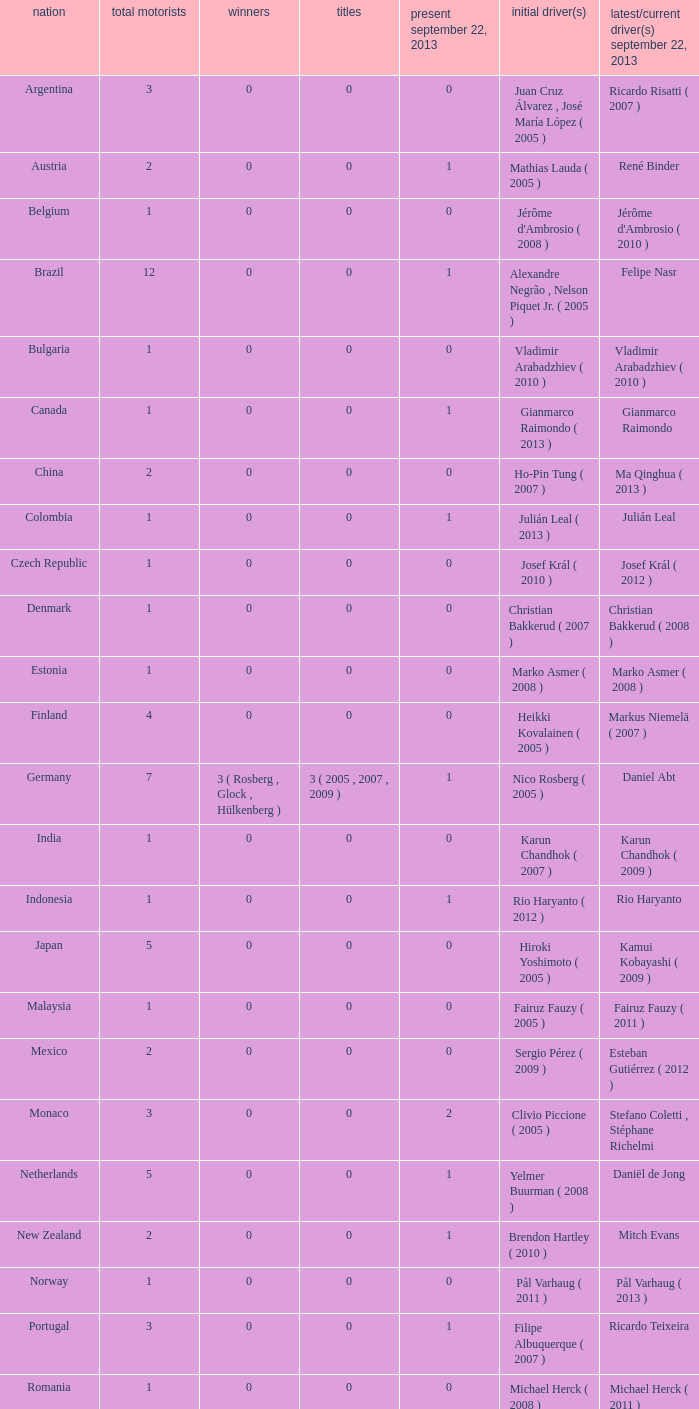How many entries are there for total drivers when the Last driver for september 22, 2013 was gianmarco raimondo? 1.0. 